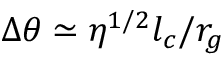<formula> <loc_0><loc_0><loc_500><loc_500>\Delta \theta \simeq \eta ^ { 1 / 2 } l _ { c } / r _ { g }</formula> 